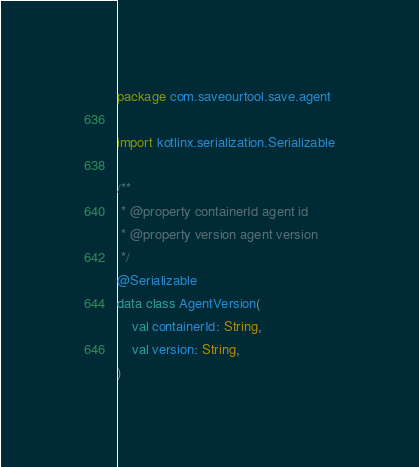Convert code to text. <code><loc_0><loc_0><loc_500><loc_500><_Kotlin_>package com.saveourtool.save.agent

import kotlinx.serialization.Serializable

/**
 * @property containerId agent id
 * @property version agent version
 */
@Serializable
data class AgentVersion(
    val containerId: String,
    val version: String,
)
</code> 